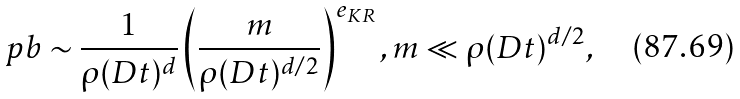<formula> <loc_0><loc_0><loc_500><loc_500>\ p b \sim \frac { 1 } { \rho ( D t ) ^ { d } } \left ( \frac { m } { \rho ( D t ) ^ { d / 2 } } \right ) ^ { e _ { K R } } , m \ll \rho ( D t ) ^ { d / 2 } ,</formula> 